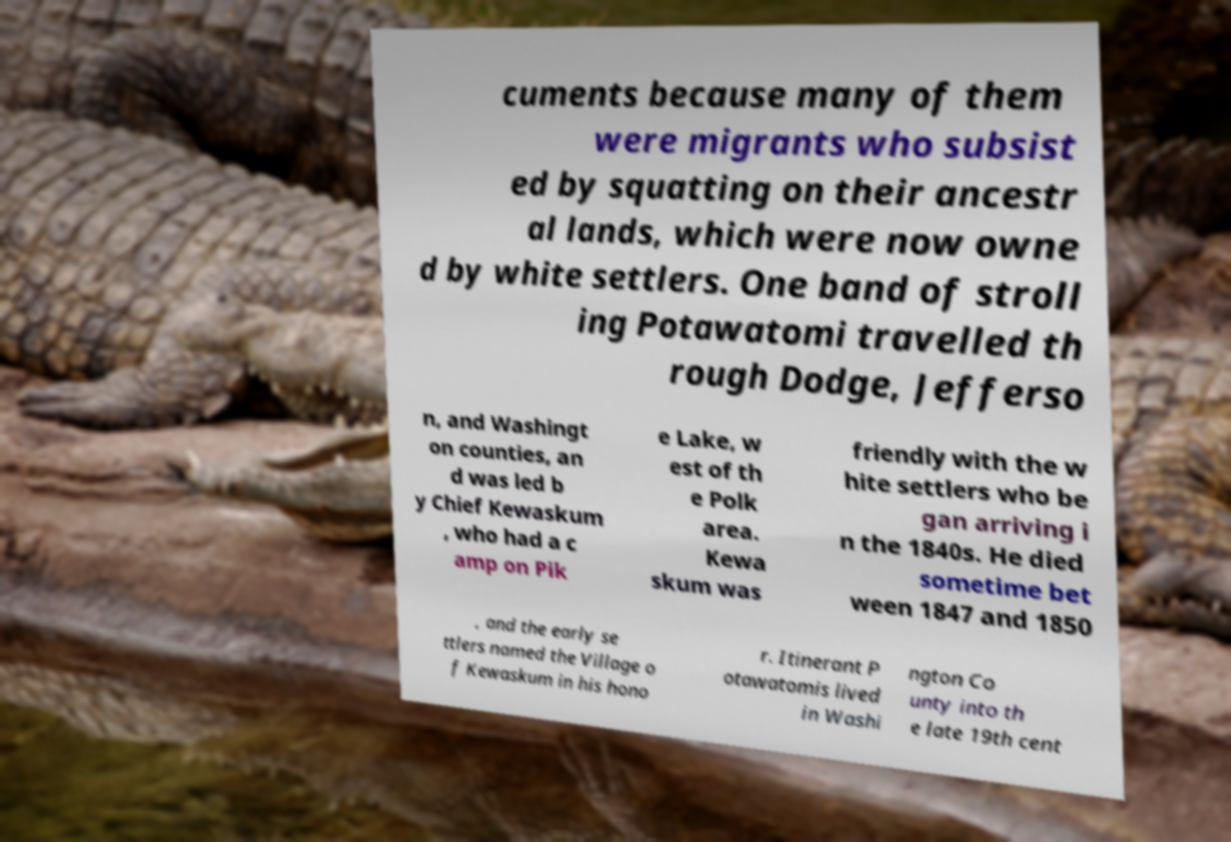Could you assist in decoding the text presented in this image and type it out clearly? cuments because many of them were migrants who subsist ed by squatting on their ancestr al lands, which were now owne d by white settlers. One band of stroll ing Potawatomi travelled th rough Dodge, Jefferso n, and Washingt on counties, an d was led b y Chief Kewaskum , who had a c amp on Pik e Lake, w est of th e Polk area. Kewa skum was friendly with the w hite settlers who be gan arriving i n the 1840s. He died sometime bet ween 1847 and 1850 , and the early se ttlers named the Village o f Kewaskum in his hono r. Itinerant P otawatomis lived in Washi ngton Co unty into th e late 19th cent 